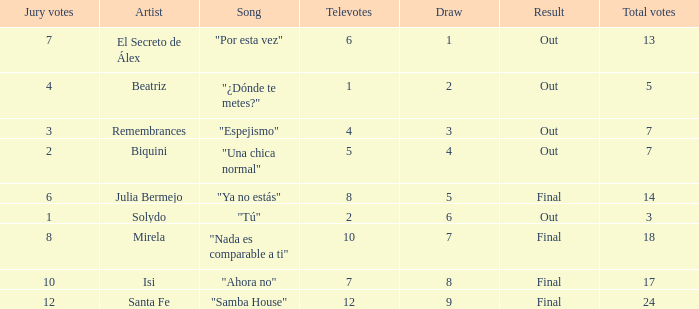Name the number of song for julia bermejo 1.0. 